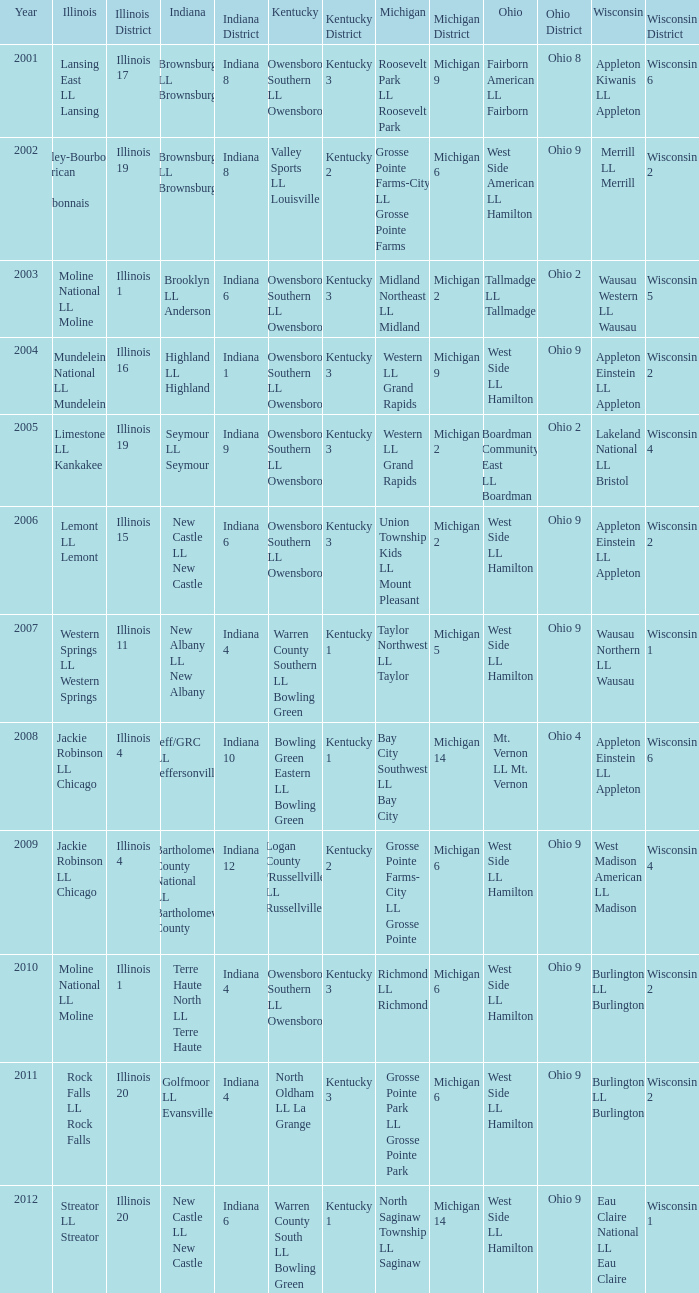What was the little league team from Kentucky when the little league team from Michigan was Grosse Pointe Farms-City LL Grosse Pointe Farms?  Valley Sports LL Louisville. 